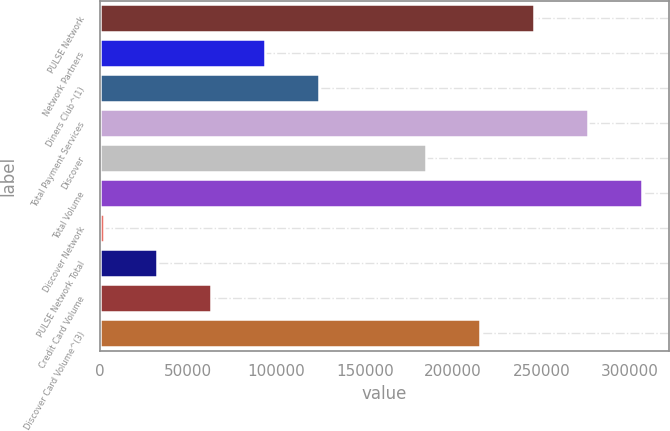Convert chart. <chart><loc_0><loc_0><loc_500><loc_500><bar_chart><fcel>PULSE Network<fcel>Network Partners<fcel>Diners Club^(1)<fcel>Total Payment Services<fcel>Discover<fcel>Total Volume<fcel>Discover Network<fcel>PULSE Network Total<fcel>Credit Card Volume<fcel>Discover Card Volume^(3)<nl><fcel>245690<fcel>93461.8<fcel>123907<fcel>276135<fcel>184799<fcel>306581<fcel>2125<fcel>32570.6<fcel>63016.2<fcel>215244<nl></chart> 